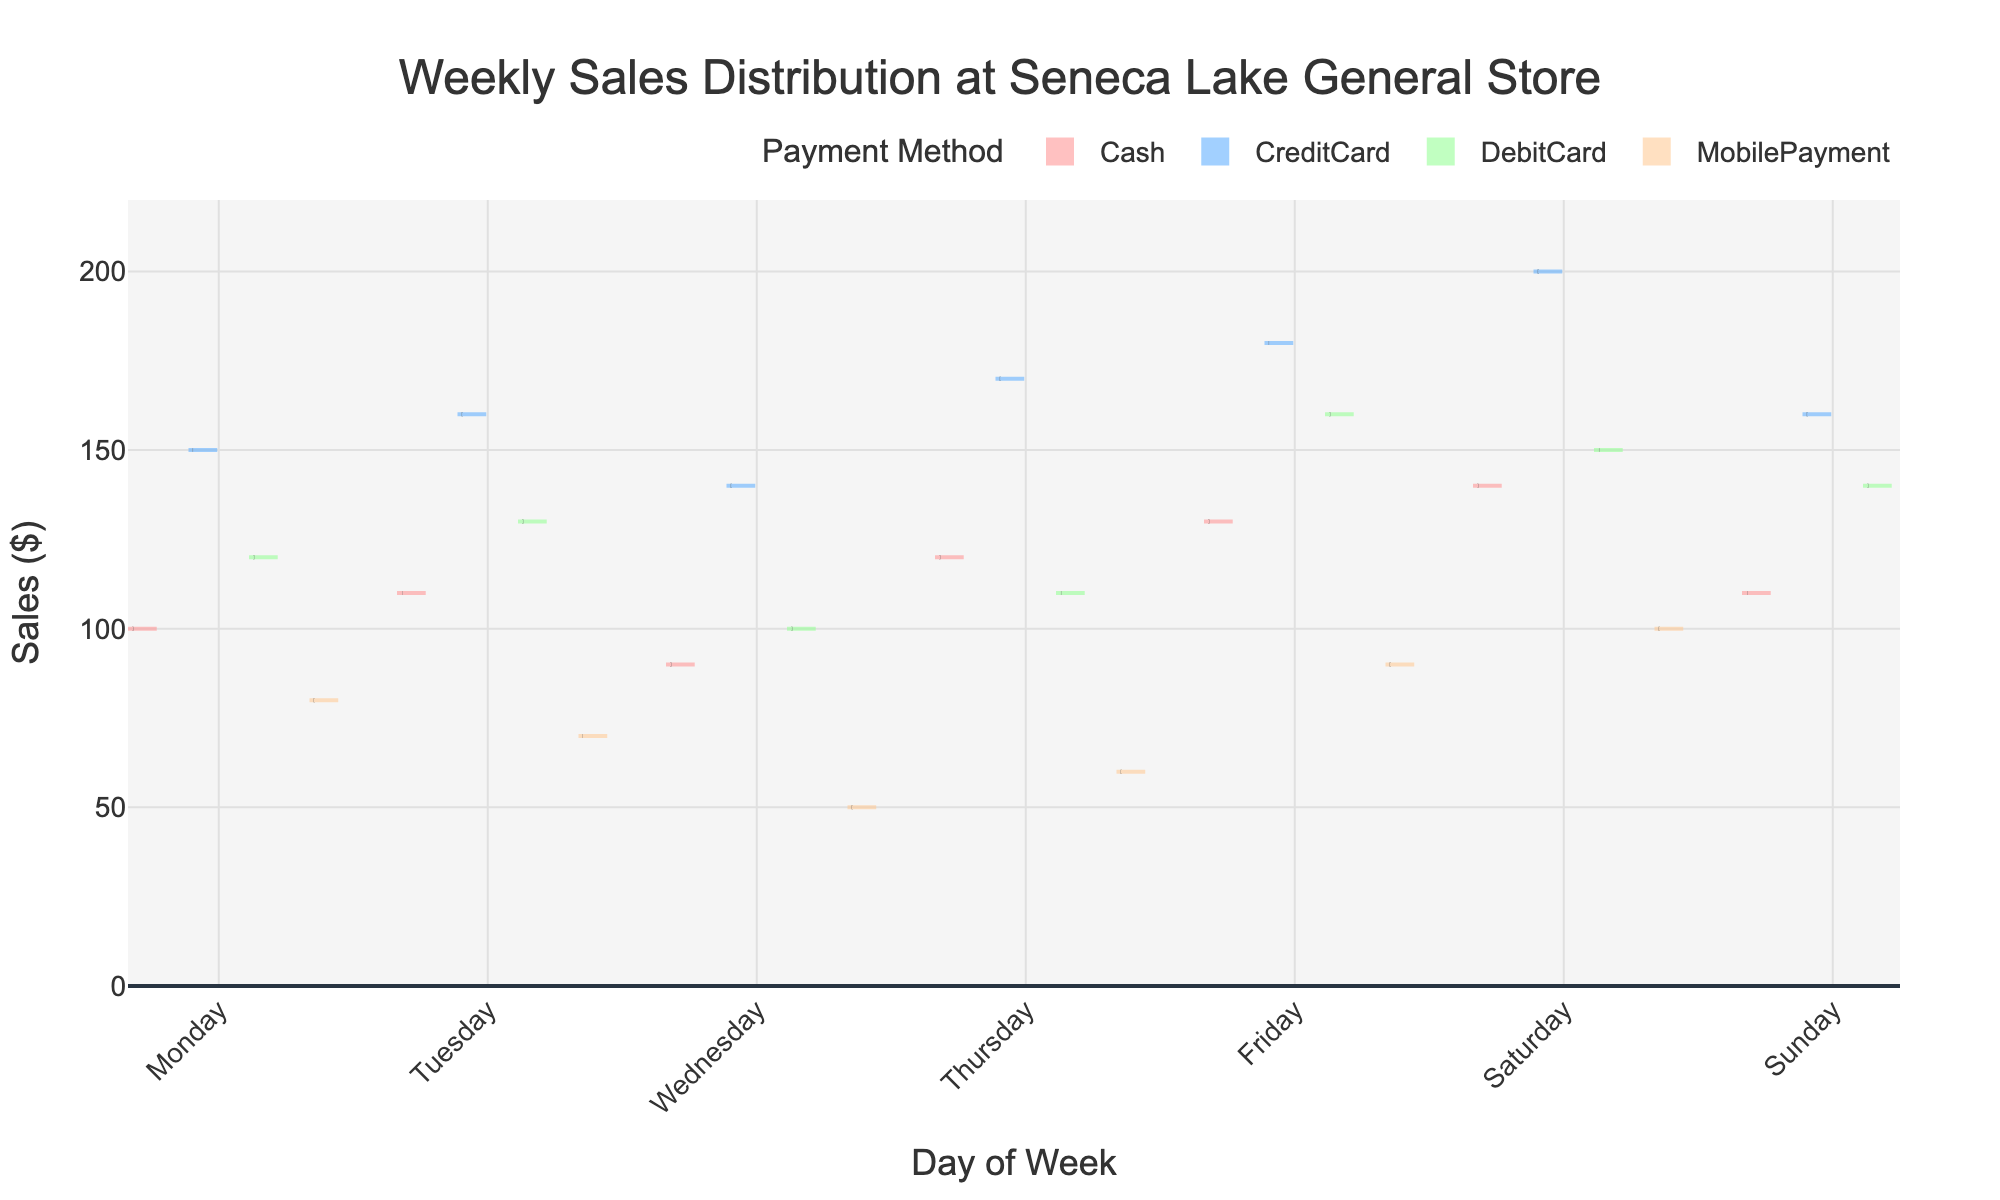What is the title of the chart? The title is written at the top of the chart, it reads "Weekly Sales Distribution at Seneca Lake General Store".
Answer: Weekly Sales Distribution at Seneca Lake General Store Which day of the week has the highest median sales for Cash payments? By observing the box plot within the violin plot for Cash payments, the whisker in Saturday's Cash payments box plot reaches the highest median compared to other days.
Answer: Saturday What is the range of sales for CreditCard payments on Saturday? The range can be determined by looking at the upper and lower limits of the box plot and whiskers for CreditCard payments on Saturday. The minimum value touches $160 and the maximum is $200.
Answer: 40 How do sales using MobilePayment on Wednesday and Thursday compare? Comparing the spread of both violin plots and where the box plots' medians lie, Wednesday has a lower distribution and median compared to Thursday.
Answer: Thursday has higher sales Which payment method shows the largest variability in sales on Friday? Variability is indicated by the spread of the violin and the length of the whiskers in the box plot. CreditCard payments on Friday have the widest spread.
Answer: CreditCard Is there a day where the sales are relatively low across all payment methods? By scanning through each day's sales distribution across all payment methods, Wednesday generally shows lower distributions in all payment methods.
Answer: Wednesday What is the median sales value for DebitCard on Tuesday? Referring to the box within the violin plot on Tuesday for DebitCard, the median line shows around $130.
Answer: 130 Which payment method has the lowest median sales on Sunday? By checking the medians indicated in the box plots across all payment methods on Sunday, MobilePayment has the lowest median.
Answer: MobilePayment 